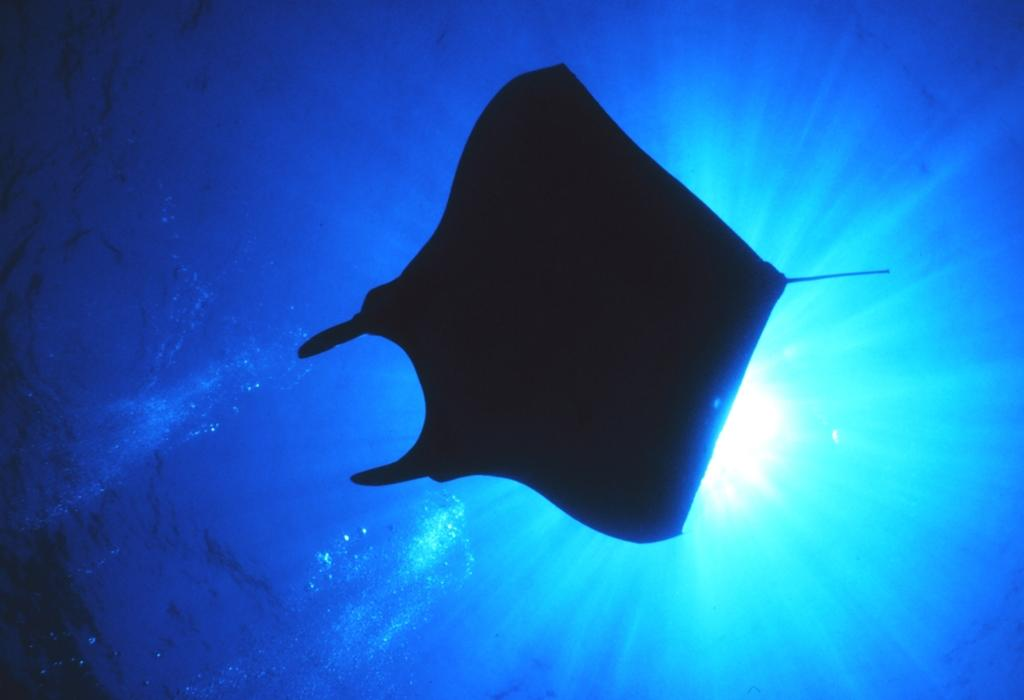What type of animal can be seen in the water in the image? There is a fish in the water in the image. What is the color of the water in the image? The water is blue in color. What type of curve can be seen in the image? There is no curve present in the image; it features a fish in blue water. What downtown area is visible in the image? There is no downtown area present in the image; it features a fish in blue water. 